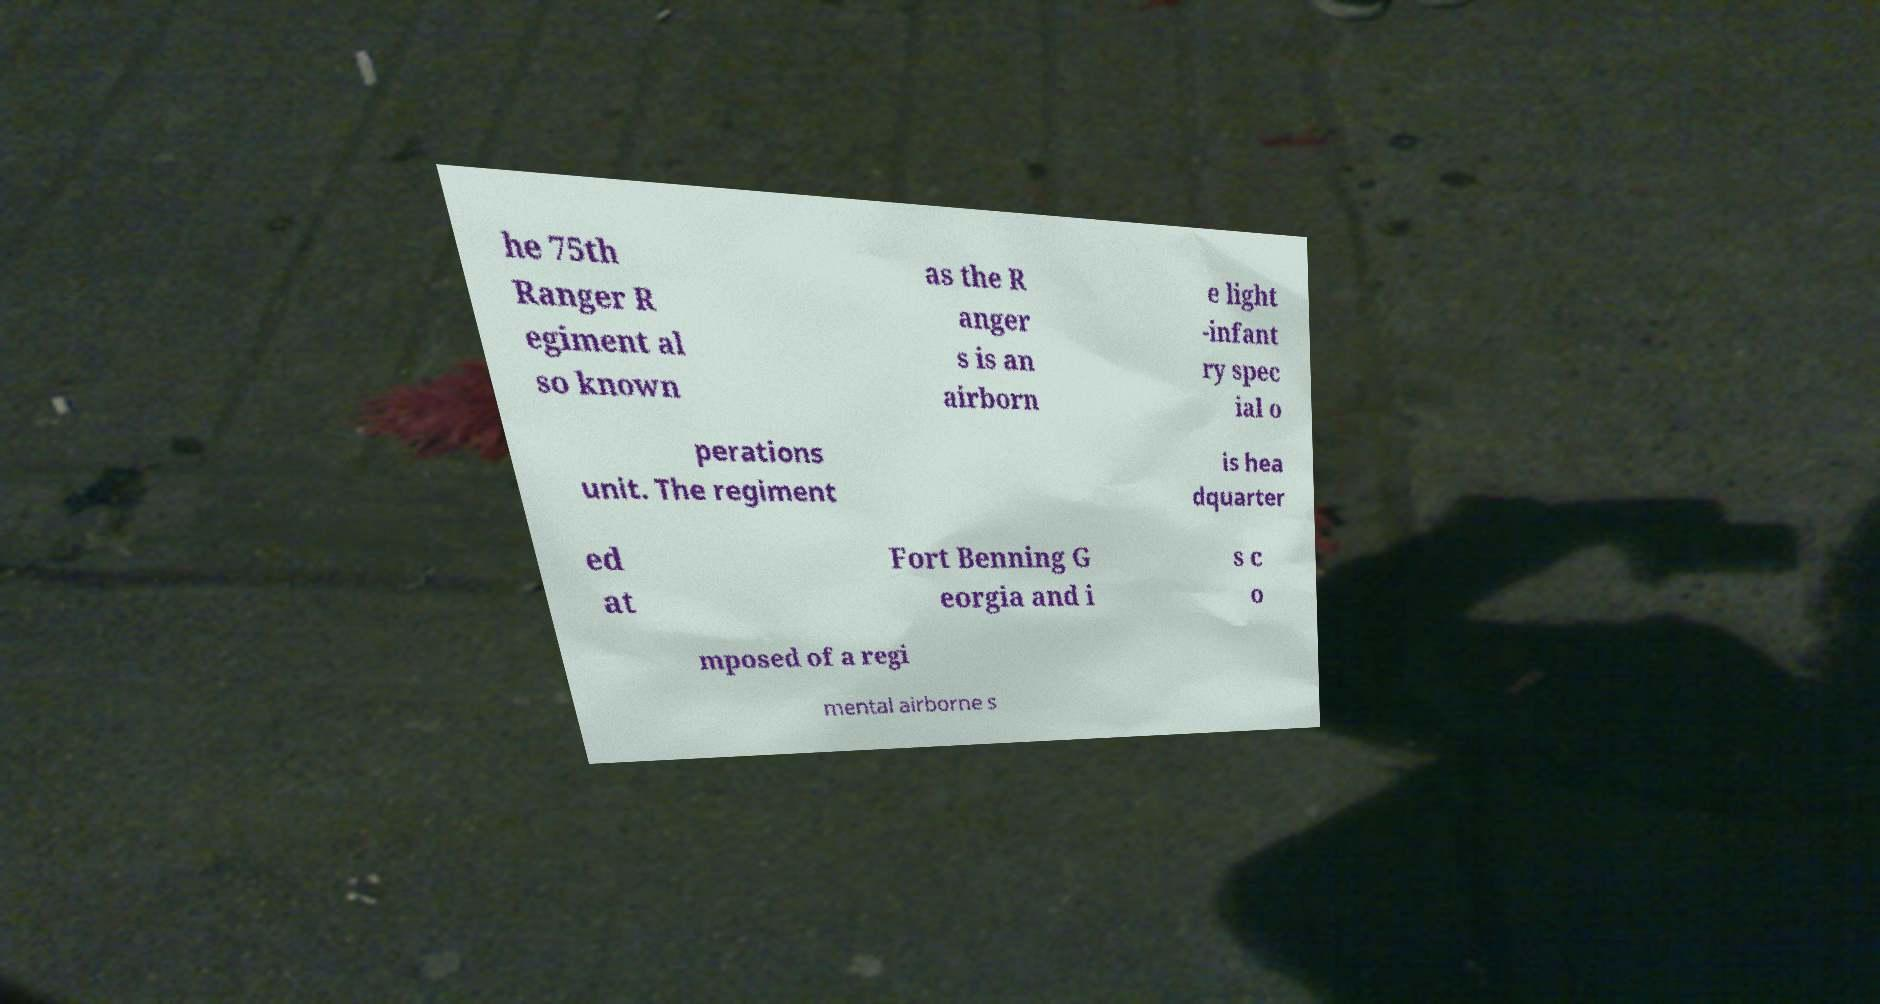Please read and relay the text visible in this image. What does it say? he 75th Ranger R egiment al so known as the R anger s is an airborn e light -infant ry spec ial o perations unit. The regiment is hea dquarter ed at Fort Benning G eorgia and i s c o mposed of a regi mental airborne s 